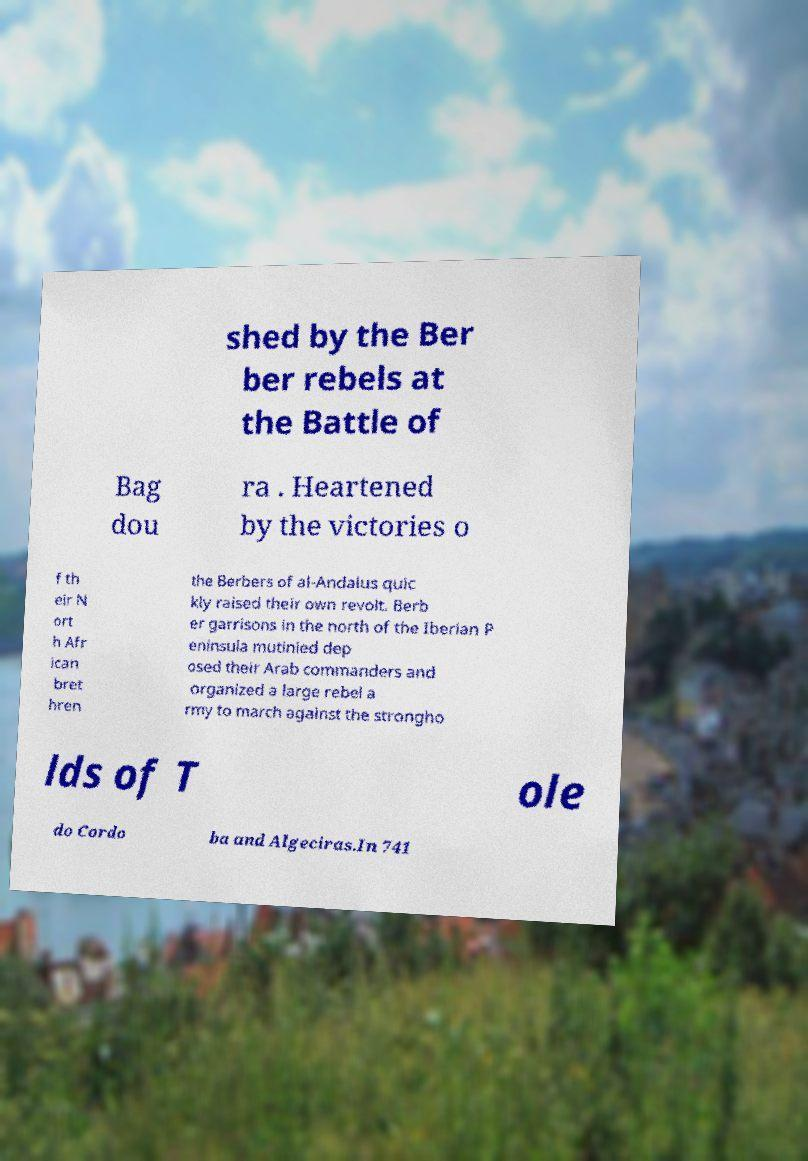Can you read and provide the text displayed in the image?This photo seems to have some interesting text. Can you extract and type it out for me? shed by the Ber ber rebels at the Battle of Bag dou ra . Heartened by the victories o f th eir N ort h Afr ican bret hren the Berbers of al-Andalus quic kly raised their own revolt. Berb er garrisons in the north of the Iberian P eninsula mutinied dep osed their Arab commanders and organized a large rebel a rmy to march against the strongho lds of T ole do Cordo ba and Algeciras.In 741 